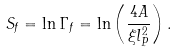Convert formula to latex. <formula><loc_0><loc_0><loc_500><loc_500>S _ { f } = \ln \Gamma _ { f } = \ln \left ( \frac { 4 A } { \xi l _ { P } ^ { 2 } } \right ) .</formula> 